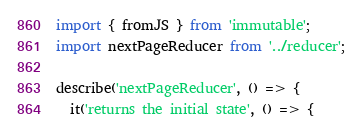Convert code to text. <code><loc_0><loc_0><loc_500><loc_500><_JavaScript_>import { fromJS } from 'immutable';
import nextPageReducer from '../reducer';

describe('nextPageReducer', () => {
  it('returns the initial state', () => {</code> 